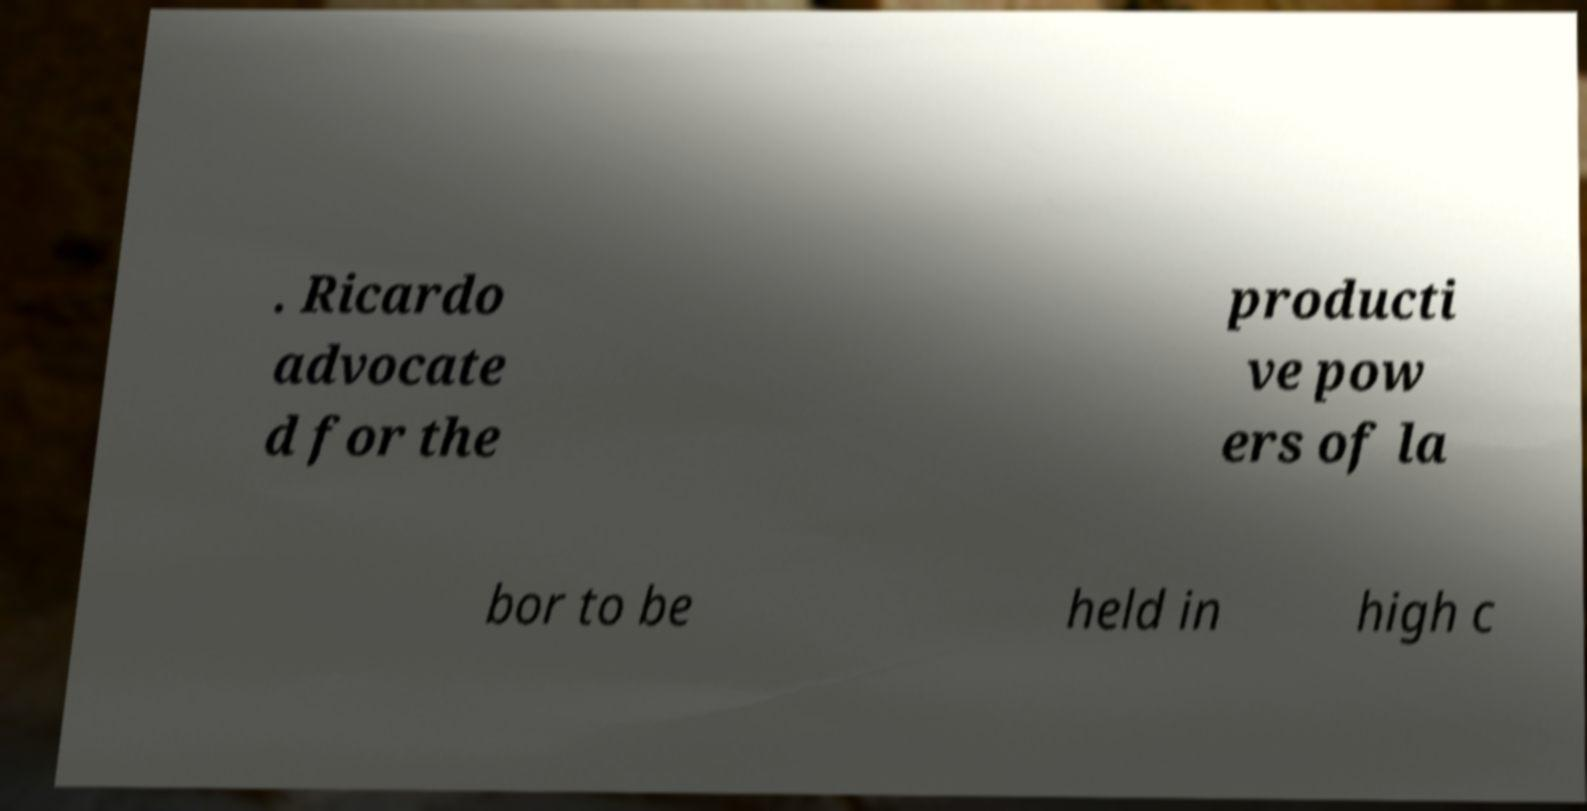Please identify and transcribe the text found in this image. . Ricardo advocate d for the producti ve pow ers of la bor to be held in high c 